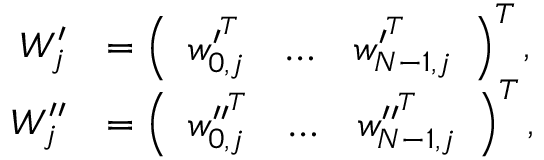Convert formula to latex. <formula><loc_0><loc_0><loc_500><loc_500>\begin{array} { r l } { W _ { j } ^ { \prime } } & { = \left ( \begin{array} { l l l } { w _ { 0 , j } ^ { \prime ^ { T } } } & { \hdots } & { w _ { N - 1 , j } ^ { \prime ^ { T } } } \end{array} \right ) ^ { T } , } \\ { W _ { j } ^ { \prime \prime } } & { = \left ( \begin{array} { l l l } { w _ { 0 , j } ^ { \prime \prime ^ { T } } } & { \hdots } & { w _ { N - 1 , j } ^ { \prime \prime ^ { T } } } \end{array} \right ) ^ { T } , } \end{array}</formula> 